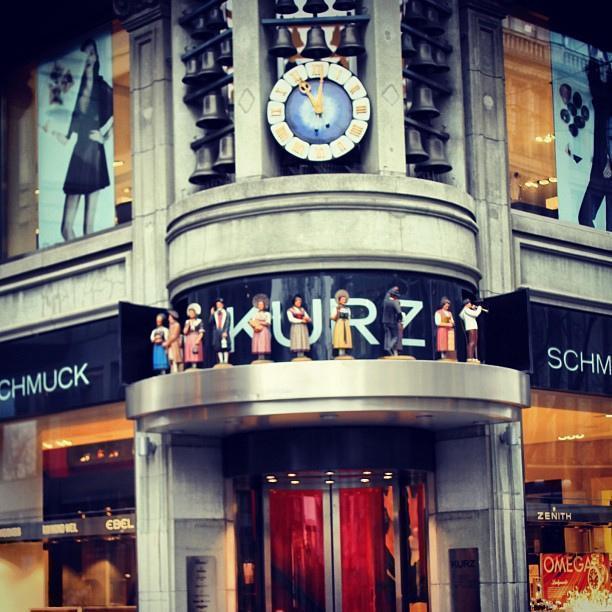What sort of wearable item is available for sale within?
Make your selection and explain in format: 'Answer: answer
Rationale: rationale.'
Options: Watch, neck gear, scarf, socks. Answer: watch.
Rationale: There are watch brands advertised in the store windows.  there is a large clock directly over the door, and the store appears to be somewhat fancy. 